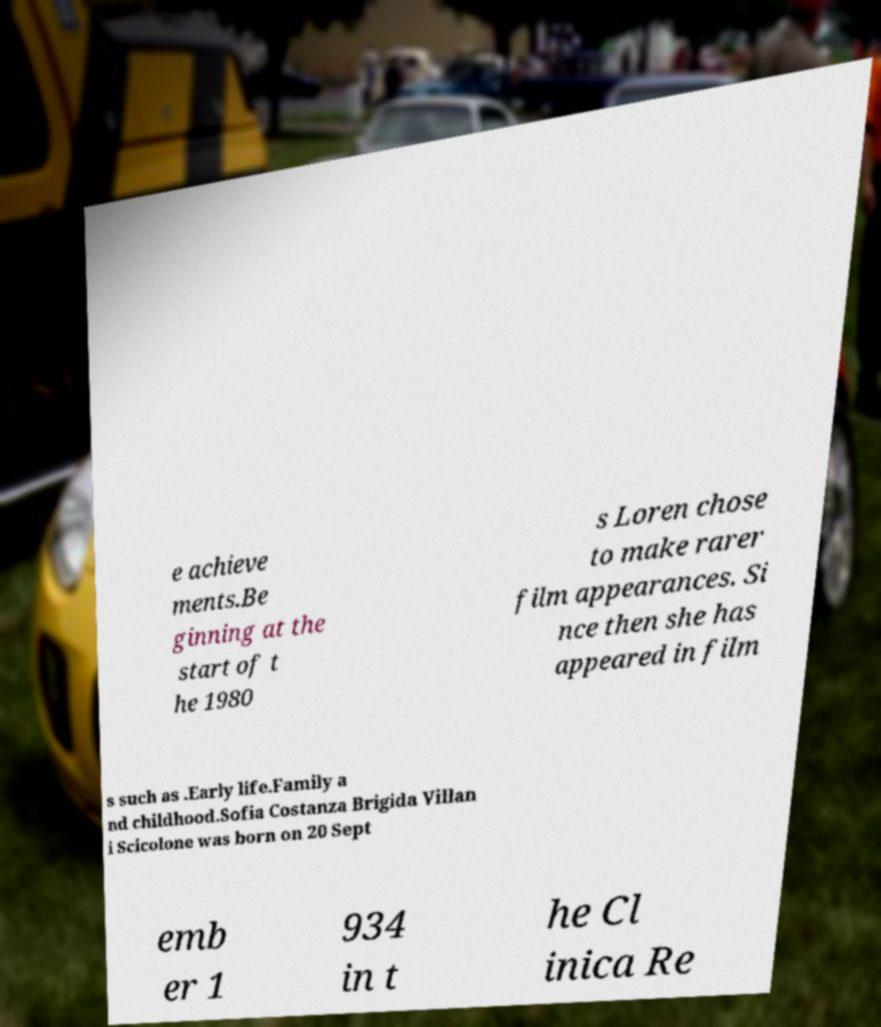Please identify and transcribe the text found in this image. e achieve ments.Be ginning at the start of t he 1980 s Loren chose to make rarer film appearances. Si nce then she has appeared in film s such as .Early life.Family a nd childhood.Sofia Costanza Brigida Villan i Scicolone was born on 20 Sept emb er 1 934 in t he Cl inica Re 